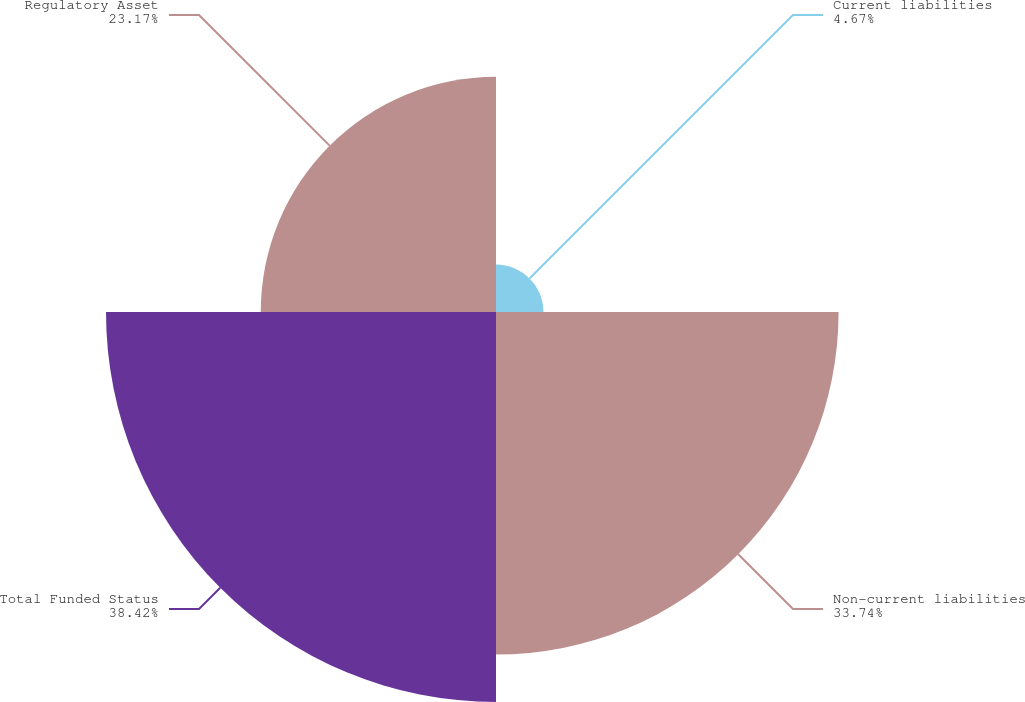Convert chart to OTSL. <chart><loc_0><loc_0><loc_500><loc_500><pie_chart><fcel>Current liabilities<fcel>Non-current liabilities<fcel>Total Funded Status<fcel>Regulatory Asset<nl><fcel>4.67%<fcel>33.74%<fcel>38.41%<fcel>23.17%<nl></chart> 